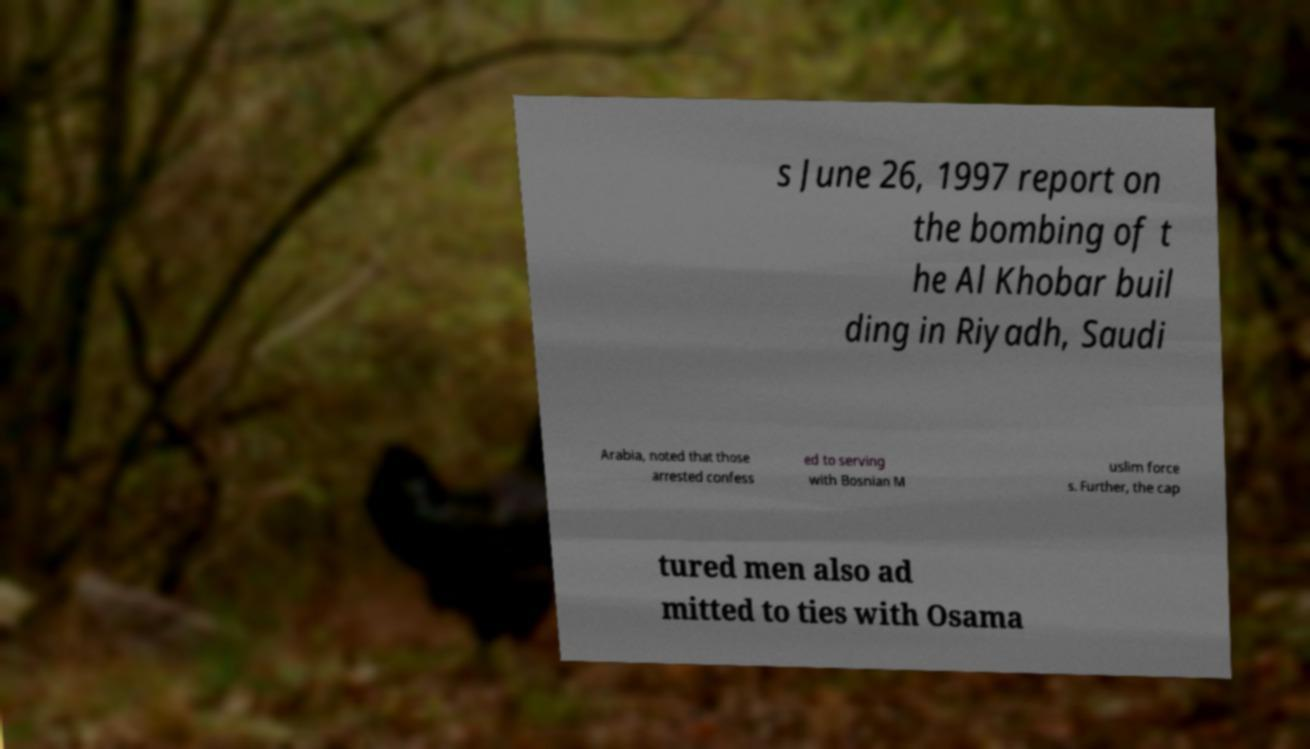Could you extract and type out the text from this image? s June 26, 1997 report on the bombing of t he Al Khobar buil ding in Riyadh, Saudi Arabia, noted that those arrested confess ed to serving with Bosnian M uslim force s. Further, the cap tured men also ad mitted to ties with Osama 